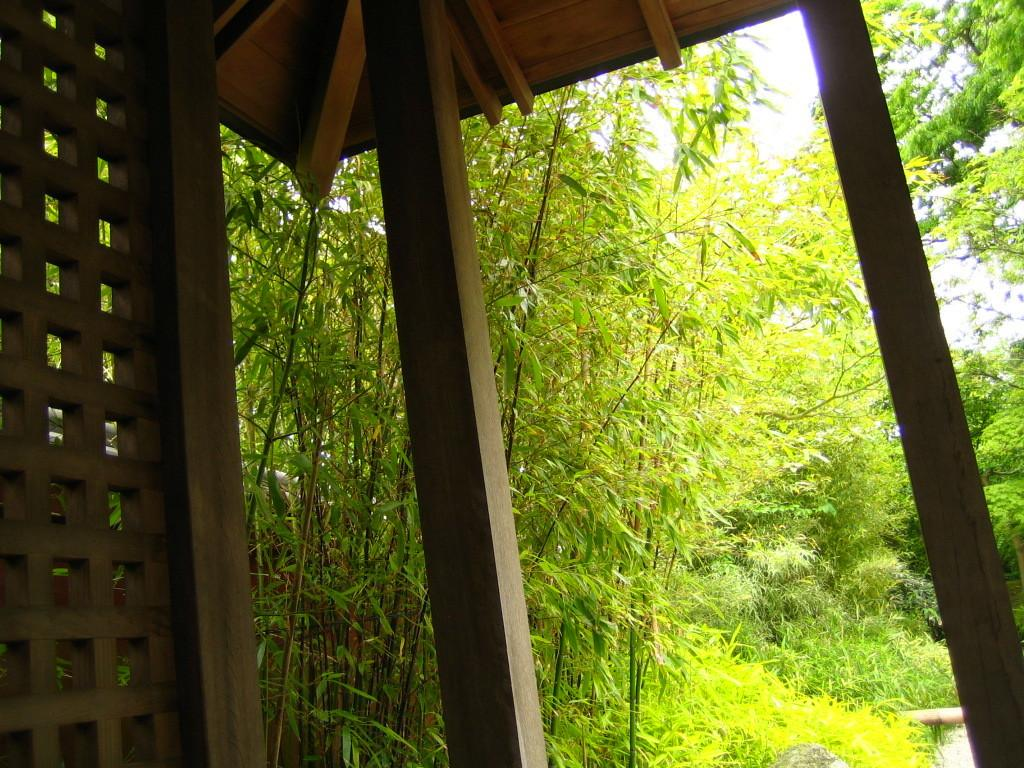What type of vegetation can be seen in the image? There are trees and plants in the image. What structure is present in the image? There is a wooden shelter in the image. Can you see any fairies interacting with the plants in the image? There are no fairies present in the image. What is the interest rate on the wooden shelter in the image? The image does not provide any information about interest rates, as it features trees, plants, and a wooden shelter. 